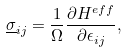<formula> <loc_0><loc_0><loc_500><loc_500>\underline { \sigma } _ { i j } = \frac { 1 } { \Omega } \frac { \partial H ^ { e f f } } { \partial \epsilon _ { i j } } ,</formula> 